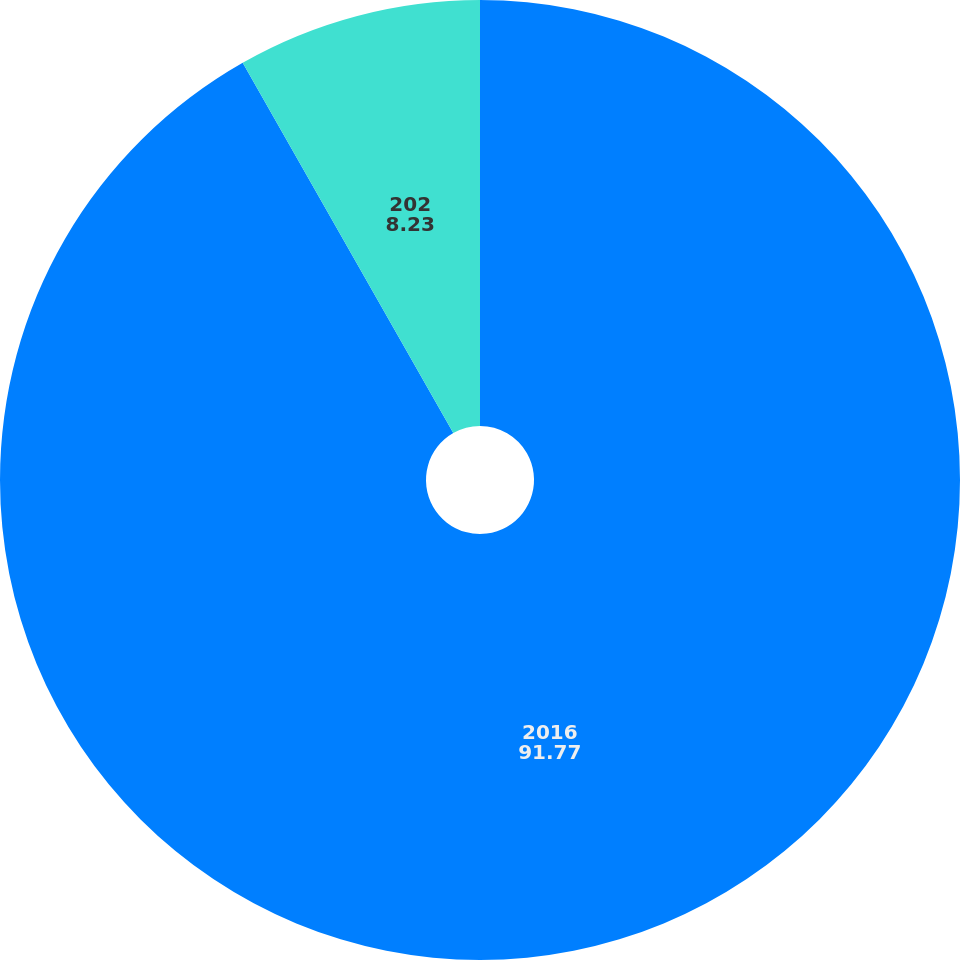Convert chart. <chart><loc_0><loc_0><loc_500><loc_500><pie_chart><fcel>2016<fcel>202<nl><fcel>91.77%<fcel>8.23%<nl></chart> 